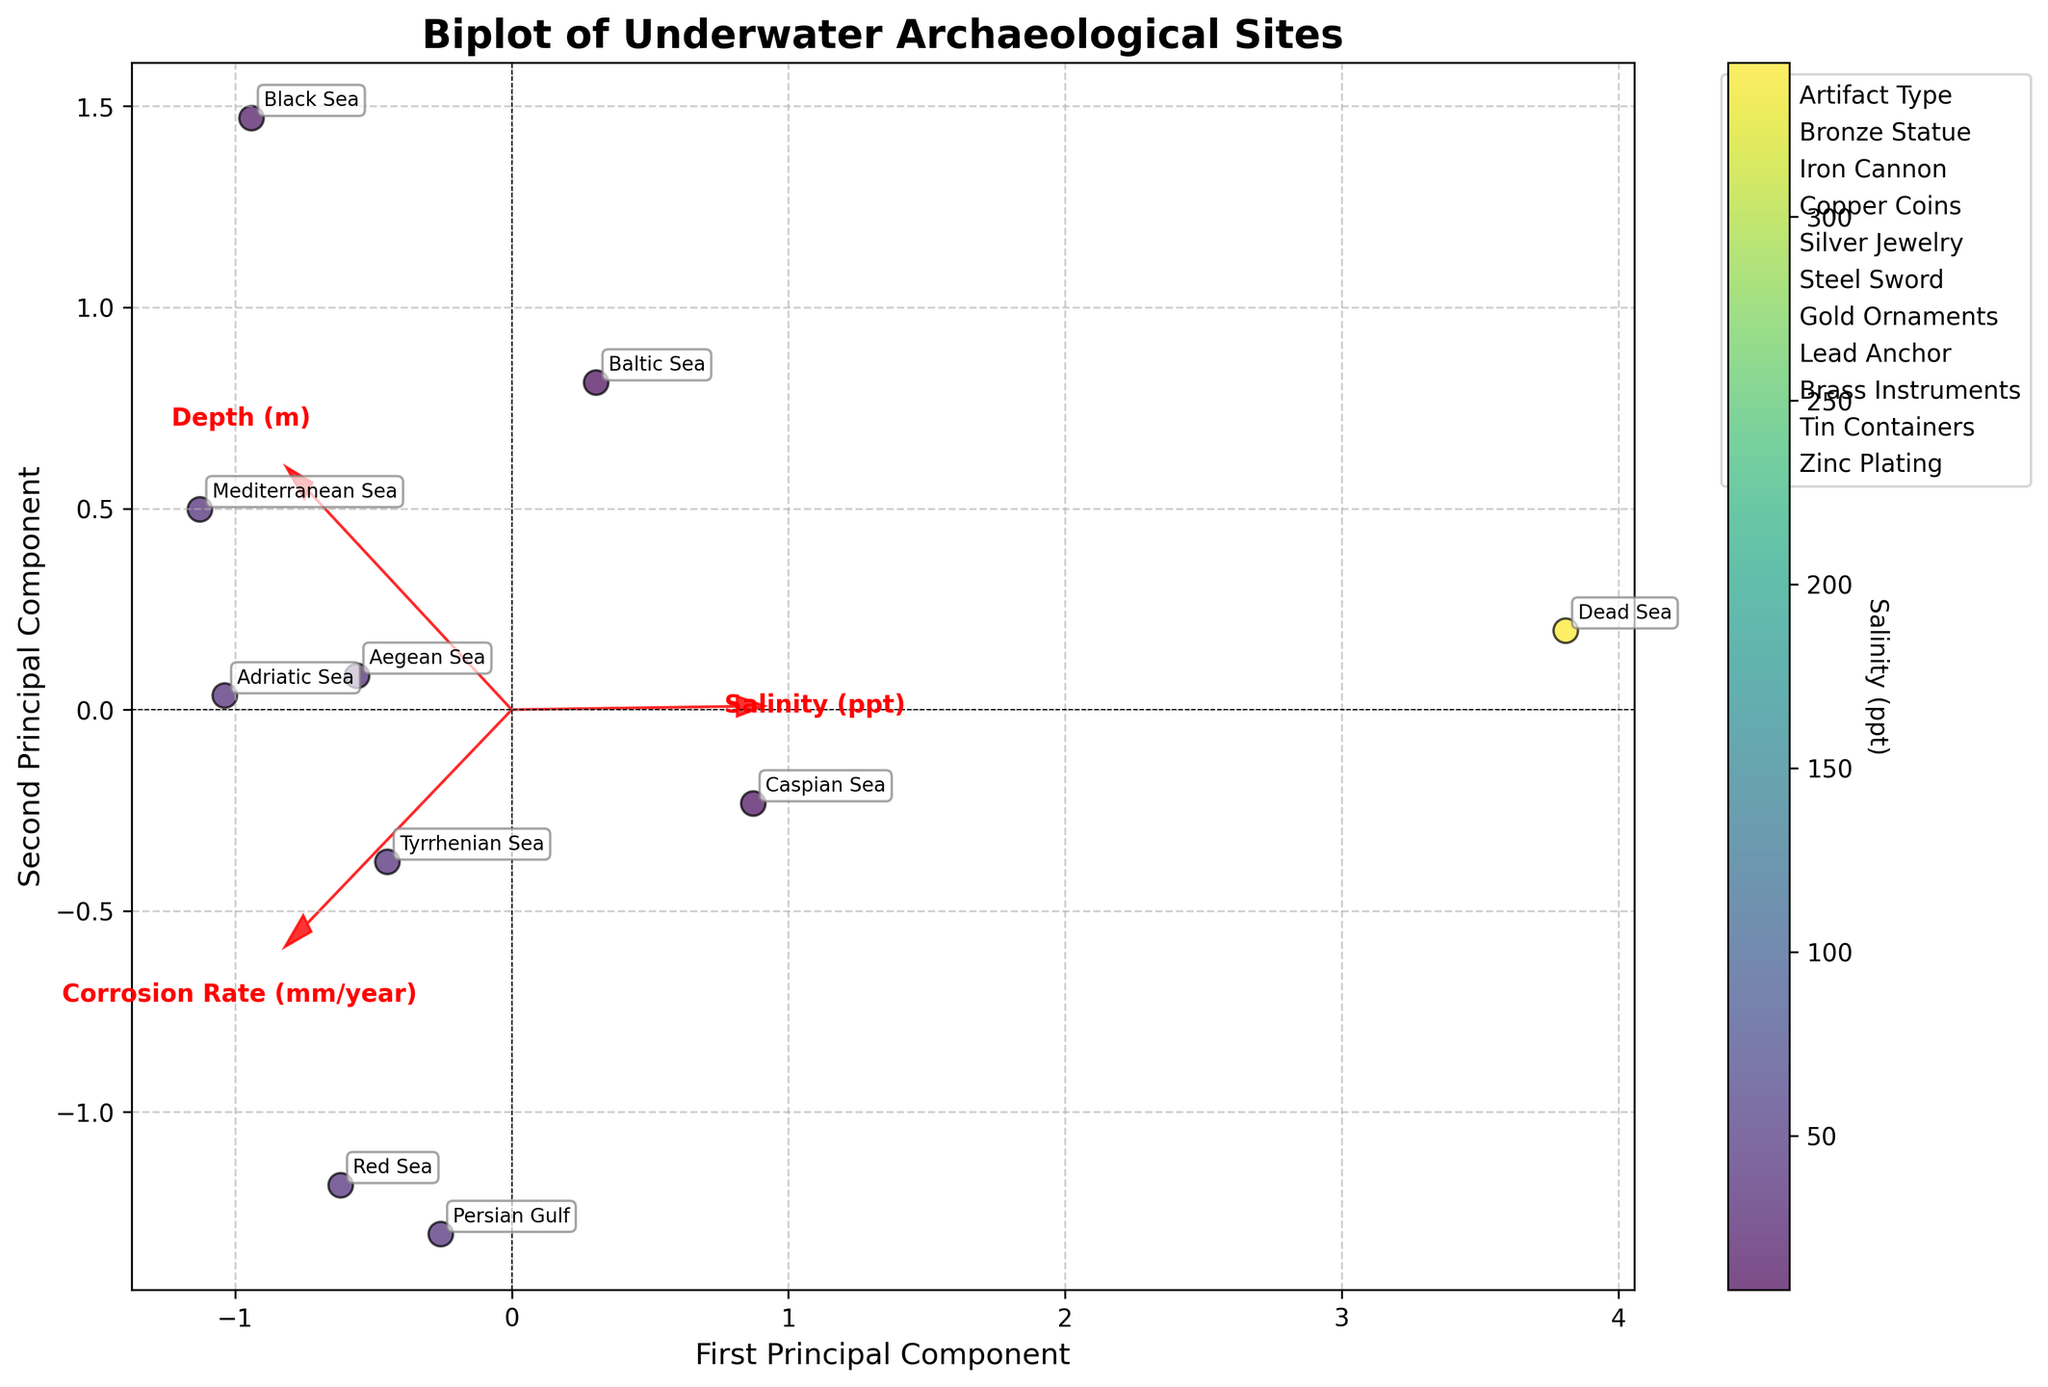How many different locations are plotted in the biplot? The biplot has labeled points representing different locations. By counting the number of unique labels, we can determine the total number of different locations.
Answer: 10 Which artifact type has the highest corrosion rate in the biplot? The biplot includes corrosion rates for different artifact types. The artifact type with the highest coordinate on the corrosion rate axis corresponds to the highest corrosion rate.
Answer: Copper Coins What is the relationship between salinity and corrosion rate as shown in the biplot? By observing the orientation and correlation of the salinity and corrosion rate vectors (arrows) in the biplot, we can infer their relationship.
Answer: Positive correlation Are there any locations where salinity is less than 10 ppt? By examining the color coding or corresponding labels near or below the 10 ppt color gradient, we determine if any location has salinity less than 10 ppt.
Answer: Yes (Baltic Sea, Dead Sea) Between the Mediterranean Sea and the Red Sea, which location shows a higher corrosion rate in the biplot? Identify and compare the positions of the Mediterranean Sea and Red Sea on the corrosion rate axis.
Answer: Red Sea Which principal component explains more variance in the data, the first or the second? The biplot typically displays principal components. By checking the axis labels, and referring to the percentage of variance explanation, identify the principal component explaining more variance.
Answer: First Principal Component For artifact types like Bronze Statue and Iron Cannon, analyze the trend in terms of depth and salinity. Locate artifacts Bronze Statue and Iron Cannon on the biplot and observe the vectors corresponding to depth and salinity to analyze their trends.
Answer: Bronze Statue (higher salinity, deeper); Iron Cannon (lower salinity, shallower) Compare the corrosion rates of artifacts in the Aegean Sea and the Caspian Sea. By locating and comparing the position of Aegean Sea and Caspian Sea on the biplot in relation to the corrosion rate axis.
Answer: Aegean Sea has a higher corrosion rate Does the biplot indicate any artifact types that show similar characteristics based on salinity, depth, and corrosion rate? Check for clustering of different artifact types which are closer together, indicating similar characteristics based on the vectors.
Answer: Bronze Statue and Tin Containers What direction is the depth vector pointing, and what does it signify for artifact locations? By observing the direction of the depth vector (arrow), we can infer how depth impacts the relative position of artifact locations in the biplot.
Answer: Pointing positive for deeper artifacts How does the corrosion rate of artifacts in the Persian Gulf compare to those in the Adriatic Sea? Locate and visually compare the coordinates associated with the corrosion rate for artifacts in the Persian Gulf and the Adriatic Sea.
Answer: Persian Gulf's corrosion rate is slightly lower than the Adriatic Sea 